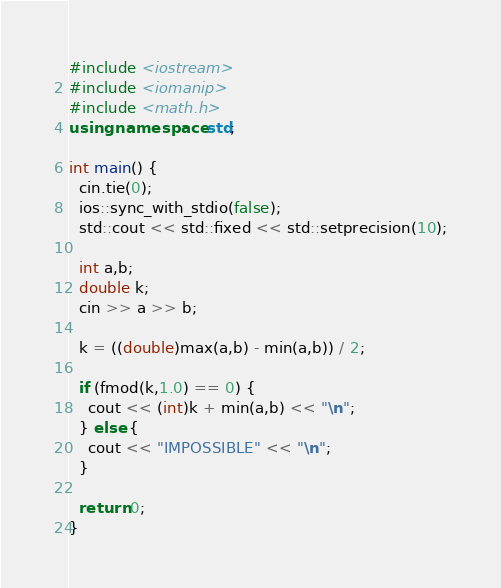Convert code to text. <code><loc_0><loc_0><loc_500><loc_500><_C++_>#include <iostream>
#include <iomanip>
#include <math.h>
using namespace std;

int main() {
  cin.tie(0);
  ios::sync_with_stdio(false);
  std::cout << std::fixed << std::setprecision(10);

  int a,b;
  double k;
  cin >> a >> b;

  k = ((double)max(a,b) - min(a,b)) / 2;

  if (fmod(k,1.0) == 0) {
    cout << (int)k + min(a,b) << "\n";
  } else {
    cout << "IMPOSSIBLE" << "\n";
  }

  return 0;
}
</code> 